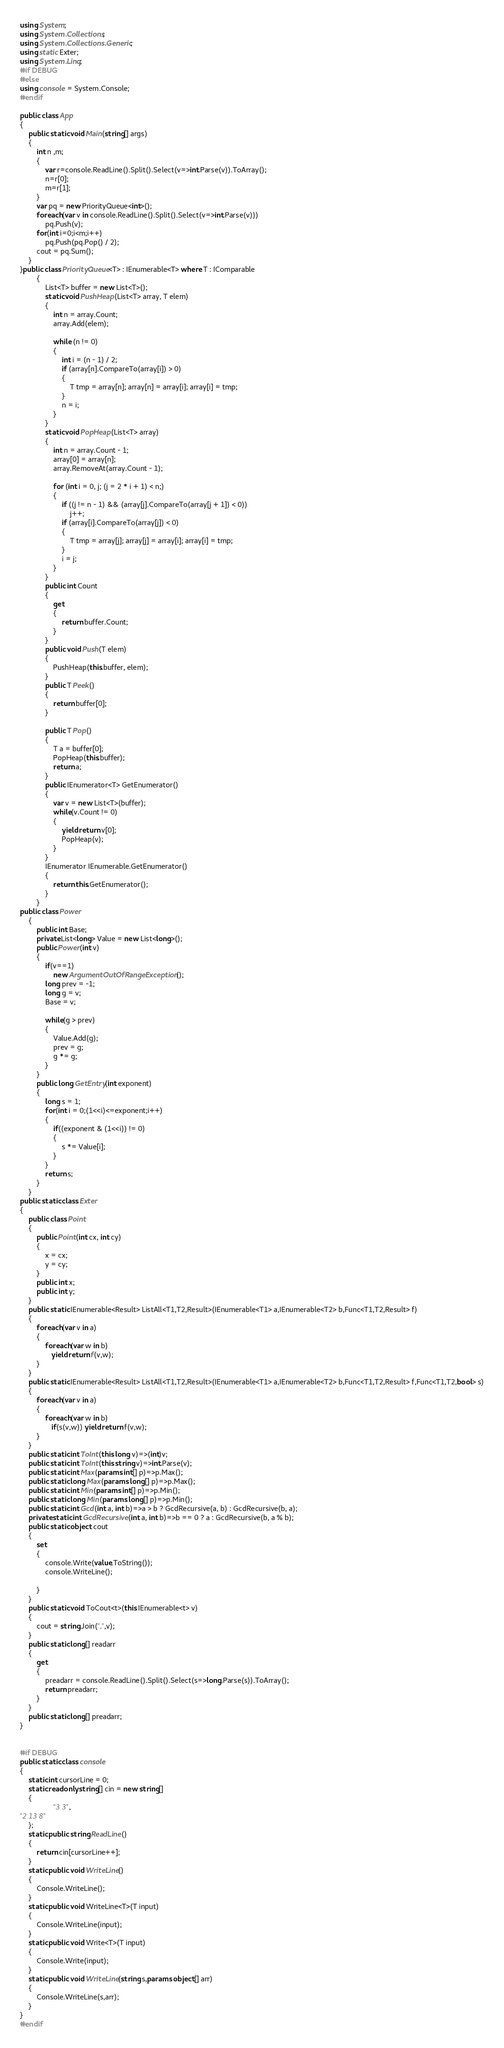<code> <loc_0><loc_0><loc_500><loc_500><_C#_>using System;
using System.Collections;
using System.Collections.Generic;
using static Exter;
using System.Linq;
#if DEBUG
#else
using console = System.Console;
#endif

public class App
{
    public static void Main(string[] args)
    {
        int n ,m;
        {
            var r=console.ReadLine().Split().Select(v=>int.Parse(v)).ToArray();
            n=r[0];
            m=r[1];
        }
        var pq = new PriorityQueue<int>();
        foreach(var v in console.ReadLine().Split().Select(v=>int.Parse(v)))
            pq.Push(v);
        for(int i=0;i<m;i++)
            pq.Push(pq.Pop() / 2);
        cout = pq.Sum();
    }
}public class PriorityQueue<T> : IEnumerable<T> where T : IComparable
        {
            List<T> buffer = new List<T>();
            static void PushHeap(List<T> array, T elem)
            {
                int n = array.Count;
                array.Add(elem);
 
                while (n != 0)
                {
                    int i = (n - 1) / 2;
                    if (array[n].CompareTo(array[i]) > 0)
                    {
                        T tmp = array[n]; array[n] = array[i]; array[i] = tmp;
                    }
                    n = i;
                }
            }
            static void PopHeap(List<T> array)
            {
                int n = array.Count - 1;
                array[0] = array[n];
                array.RemoveAt(array.Count - 1);
 
                for (int i = 0, j; (j = 2 * i + 1) < n;)
                {
                    if ((j != n - 1) && (array[j].CompareTo(array[j + 1]) < 0))
                        j++;
                    if (array[i].CompareTo(array[j]) < 0)
                    {
                        T tmp = array[j]; array[j] = array[i]; array[i] = tmp;
                    }
                    i = j;
                }
            }
            public int Count
            {
                get
                {
                    return buffer.Count;
                }
            }
            public void Push(T elem)
            {
                PushHeap(this.buffer, elem);
            }
            public T Peek()
            {
                return buffer[0];
            }
 
            public T Pop()
            {
                T a = buffer[0];
                PopHeap(this.buffer);
                return a;
            }
            public IEnumerator<T> GetEnumerator()
            {
                var v = new List<T>(buffer);
                while(v.Count != 0)
                {
                    yield return v[0];
                    PopHeap(v);
                }
            }
            IEnumerator IEnumerable.GetEnumerator()
            {
                return this.GetEnumerator();
            }
        }
public class Power
    {
        public int Base;
        private List<long> Value = new List<long>();
        public Power(int v)
        {
            if(v==1)
                new ArgumentOutOfRangeException();
            long prev = -1;
            long g = v;
            Base = v;
            
            while(g > prev)
            {
                Value.Add(g);
                prev = g;
                g *= g;
            }
        }
        public long GetEntry(int exponent)
        {
            long s = 1;
            for(int i = 0;(1<<i)<=exponent;i++)
            {
                if((exponent & (1<<i)) != 0)
                {
                    s *= Value[i];
                }
            }
            return s;
        }
    }
public static class Exter
{
    public class Point
    {
        public Point(int cx, int cy)
        {
            x = cx;
            y = cy;
        }
        public int x;
        public int y;
    }
    public static IEnumerable<Result> ListAll<T1,T2,Result>(IEnumerable<T1> a,IEnumerable<T2> b,Func<T1,T2,Result> f)
    {
        foreach(var v in a)
        {
            foreach(var w in b)
               yield return f(v,w);
        }
    }
    public static IEnumerable<Result> ListAll<T1,T2,Result>(IEnumerable<T1> a,IEnumerable<T2> b,Func<T1,T2,Result> f,Func<T1,T2,bool> s)
    {
        foreach(var v in a)
        {
            foreach(var w in b)
               if(s(v,w)) yield return f(v,w);
        }
    }
    public static int ToInt(this long v)=>(int)v;
    public static int ToInt(this string v)=>int.Parse(v);
    public static int Max(params int[] p)=>p.Max();
    public static long Max(params long[] p)=>p.Max();
    public static int Min(params int[] p)=>p.Min();
    public static long Min(params long[] p)=>p.Min();
    public static int Gcd(int a, int b)=>a > b ? GcdRecursive(a, b) : GcdRecursive(b, a);
    private static int GcdRecursive(int a, int b)=>b == 0 ? a : GcdRecursive(b, a % b);
    public static object cout
    {
        set
        {
            console.Write(value.ToString());
            console.WriteLine();
            
        }
    }
    public static void ToCout<t>(this IEnumerable<t> v)
    {
        cout = string.Join(",",v);
    }
    public static long[] readarr
    {
        get 
        {
            preadarr = console.ReadLine().Split().Select(s=>long.Parse(s)).ToArray();
            return preadarr;
        }
    }
    public static long[] preadarr;
}


#if DEBUG
public static class console
{
    static int cursorLine = 0;
    static readonly string[] cin = new string[]
    {
                "3 3",
"2 13 8"
    };
    static public string ReadLine()
    { 
        return cin[cursorLine++];
    }
    static public void WriteLine()
    {
        Console.WriteLine();
    }
    static public void WriteLine<T>(T input)
    {
        Console.WriteLine(input);
    }
    static public void Write<T>(T input)
    {
        Console.Write(input);
    }
    static public void WriteLine(string s,params object[] arr)
    {
        Console.WriteLine(s,arr);
    }
}
#endif
</code> 